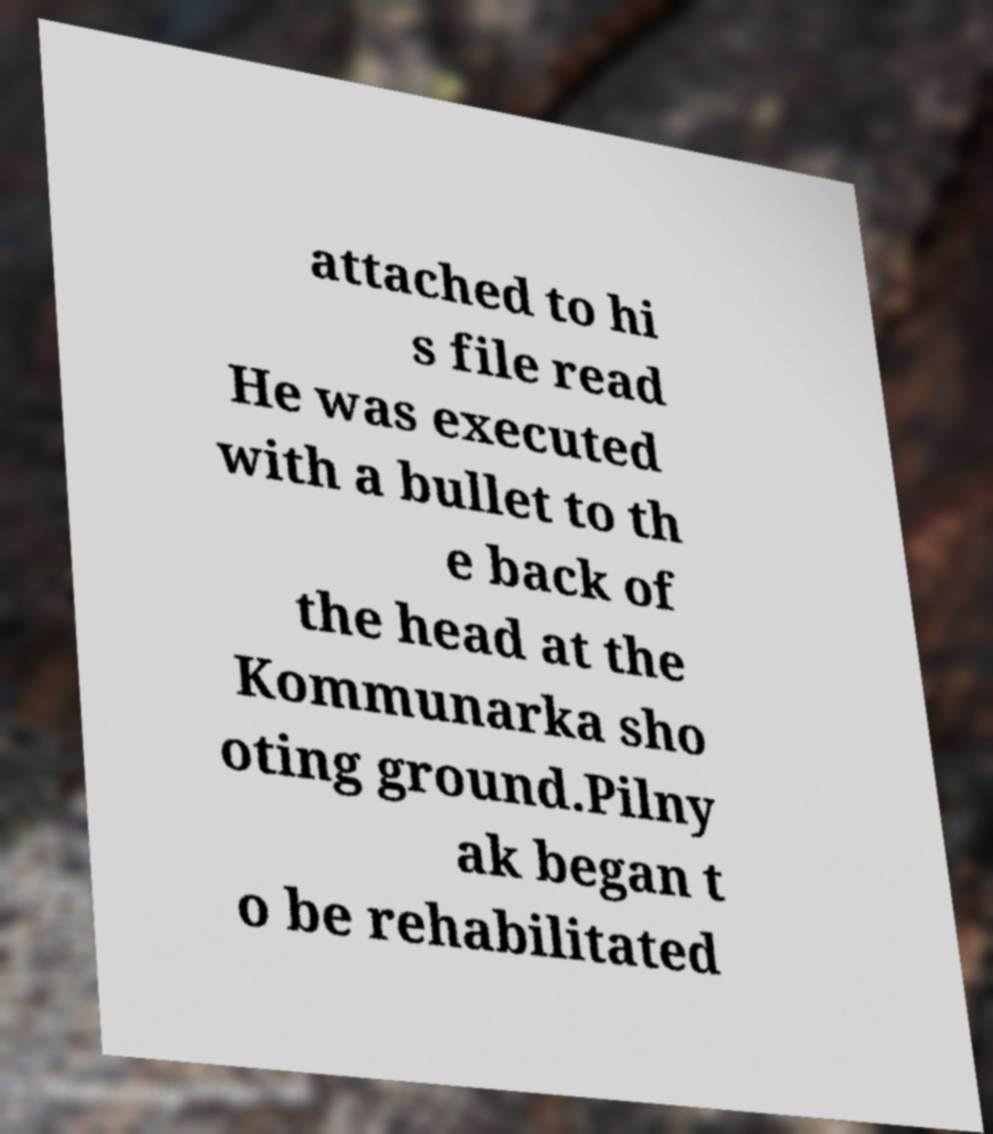What messages or text are displayed in this image? I need them in a readable, typed format. attached to hi s file read He was executed with a bullet to th e back of the head at the Kommunarka sho oting ground.Pilny ak began t o be rehabilitated 